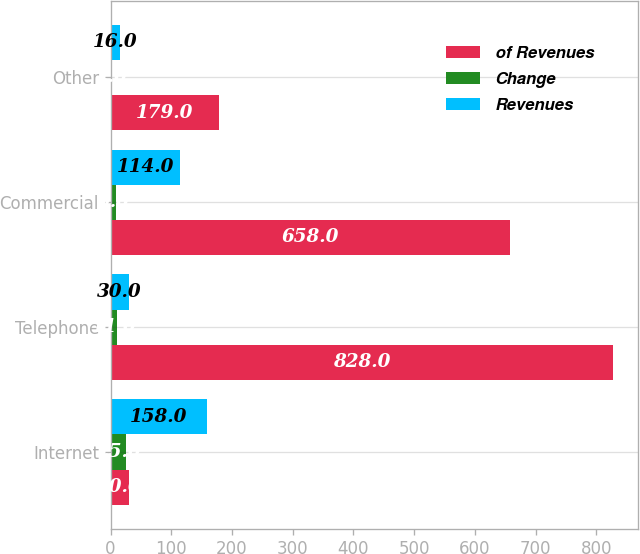Convert chart to OTSL. <chart><loc_0><loc_0><loc_500><loc_500><stacked_bar_chart><ecel><fcel>Internet<fcel>Telephone<fcel>Commercial<fcel>Other<nl><fcel>of Revenues<fcel>30<fcel>828<fcel>658<fcel>179<nl><fcel>Change<fcel>25<fcel>11<fcel>9<fcel>2<nl><fcel>Revenues<fcel>158<fcel>30<fcel>114<fcel>16<nl></chart> 